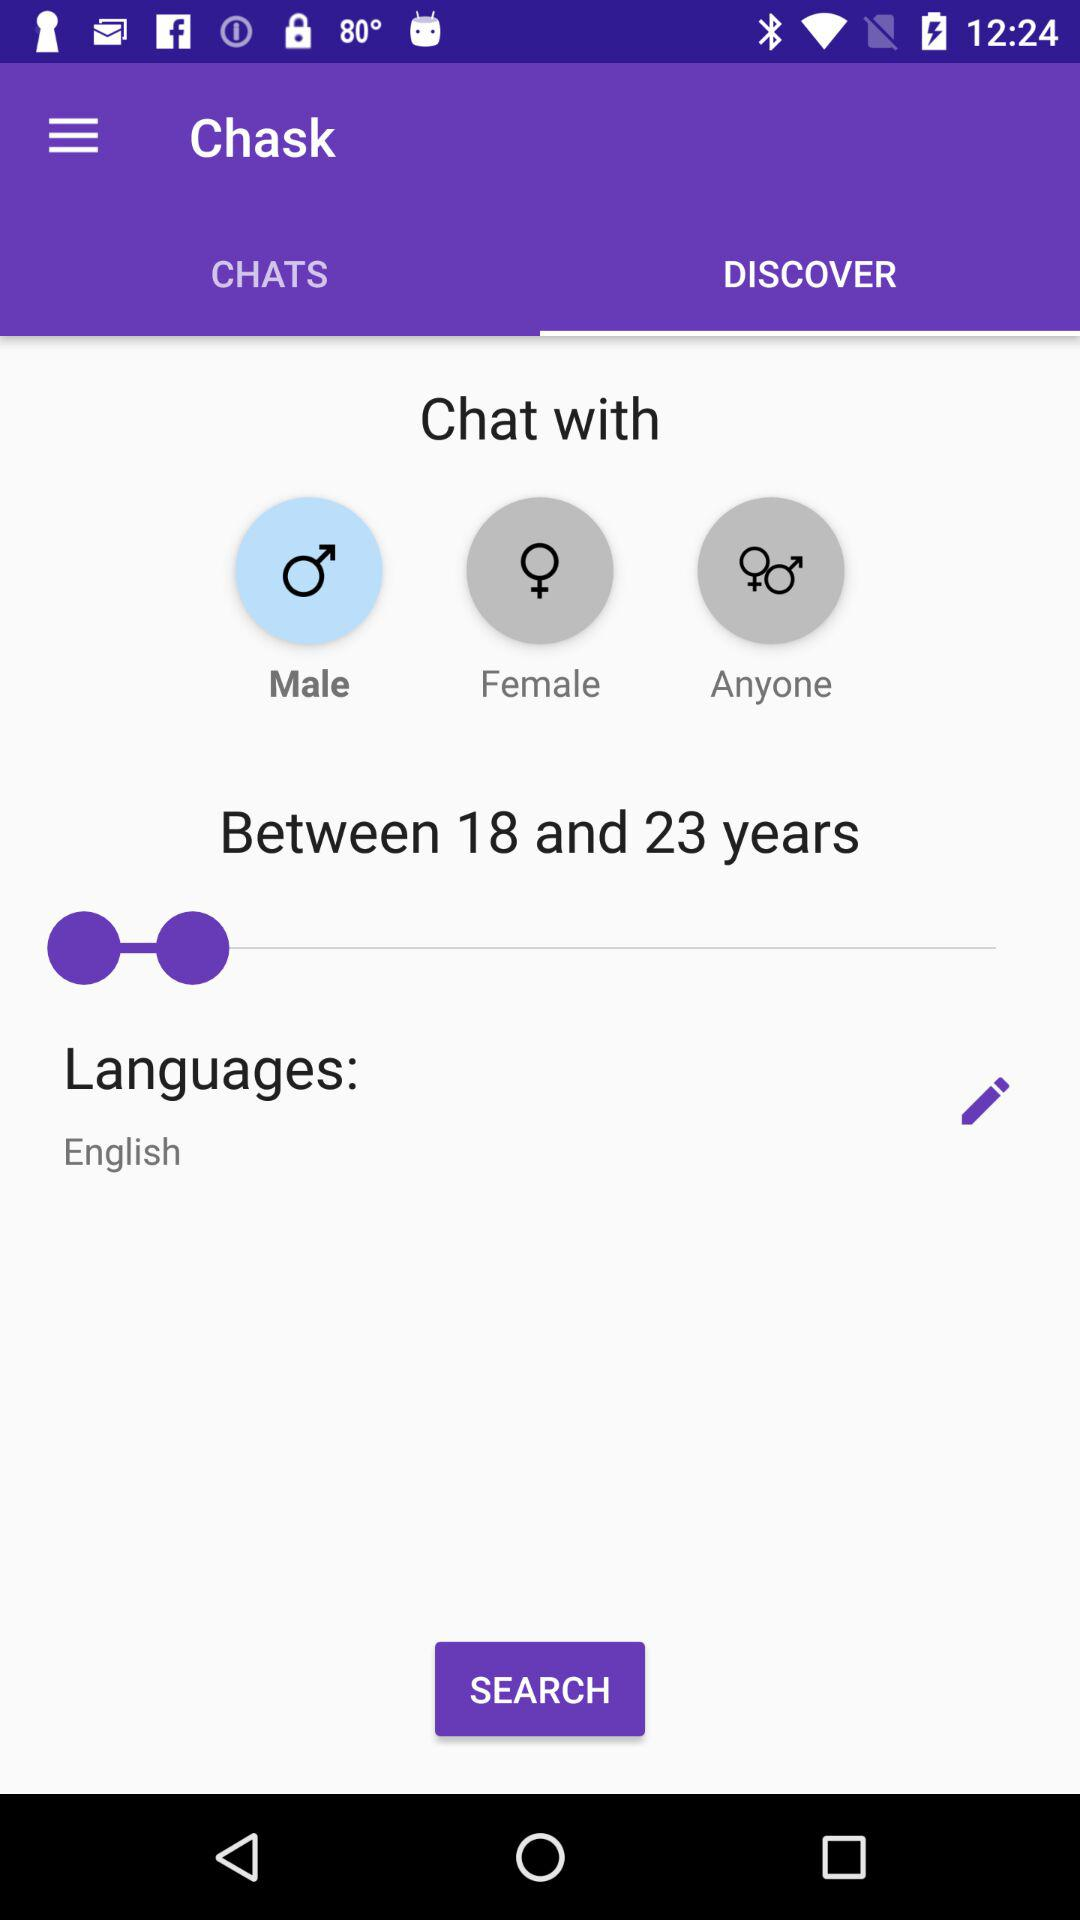What language is given here? The given language is "English". 